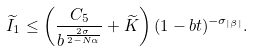<formula> <loc_0><loc_0><loc_500><loc_500>\widetilde { I } _ { 1 } \leq \left ( \frac { C _ { 5 } } { b ^ { \frac { 2 \sigma } { 2 - N \alpha } } } + \widetilde { K } \right ) ( 1 - b t ) ^ { - \sigma _ { | \beta | } } .</formula> 